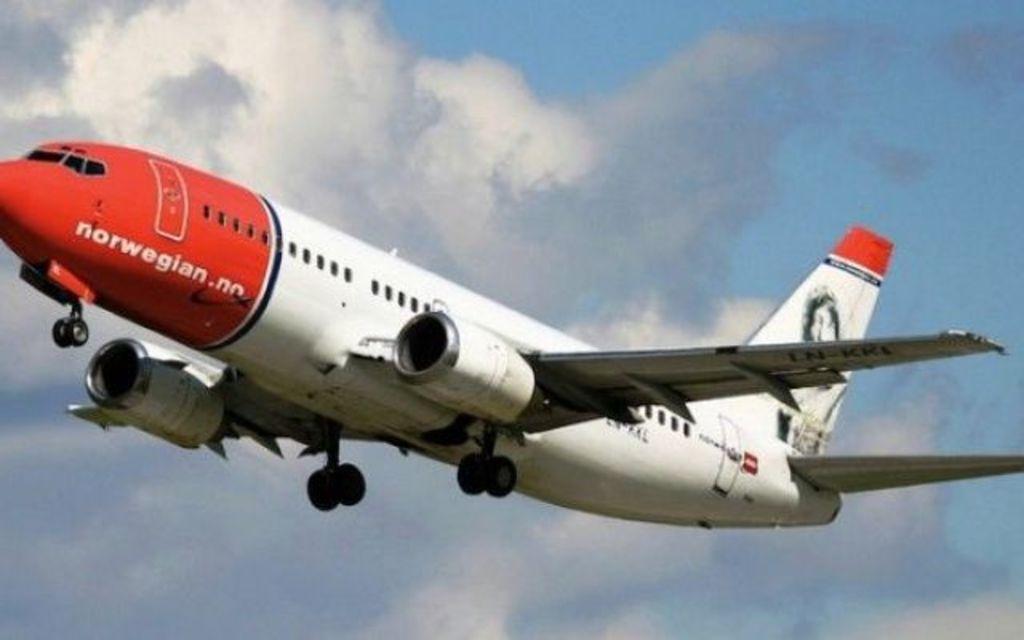How would you summarize this image in a sentence or two? This picture is clicked outside. In the center we can see an airplane flying in the sky. In the background we can see the sky and the clouds. 